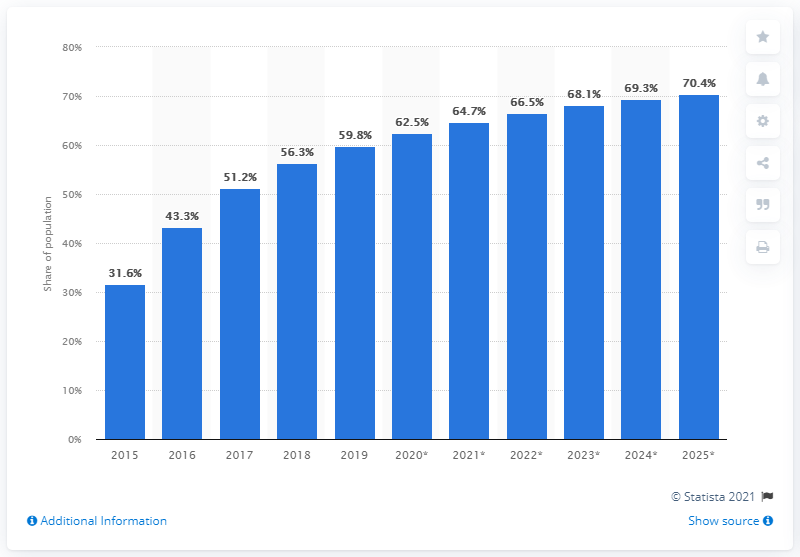List a handful of essential elements in this visual. The projected growth rate of mobile internet penetration in Mexico by 2025 is expected to reach 70.4%. 